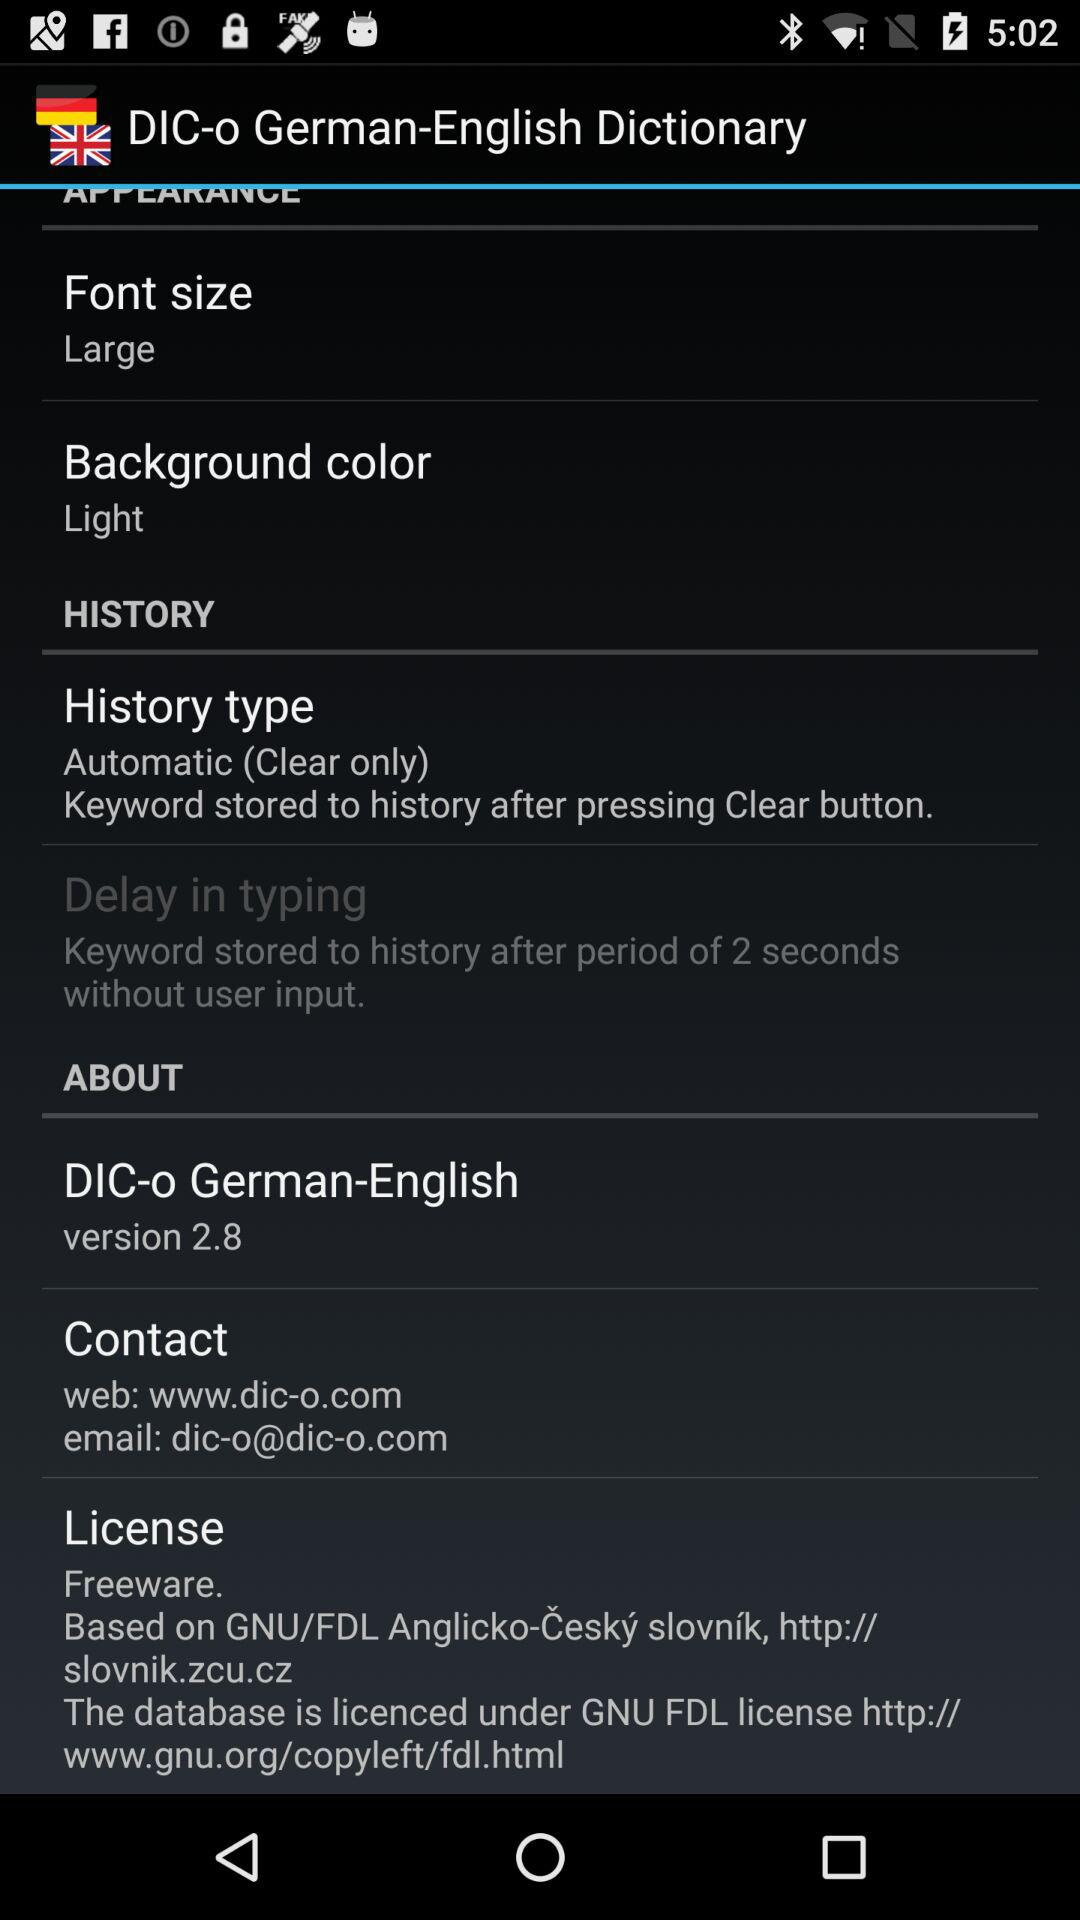What is the version of "DIC-o"? The version is 2.8. 